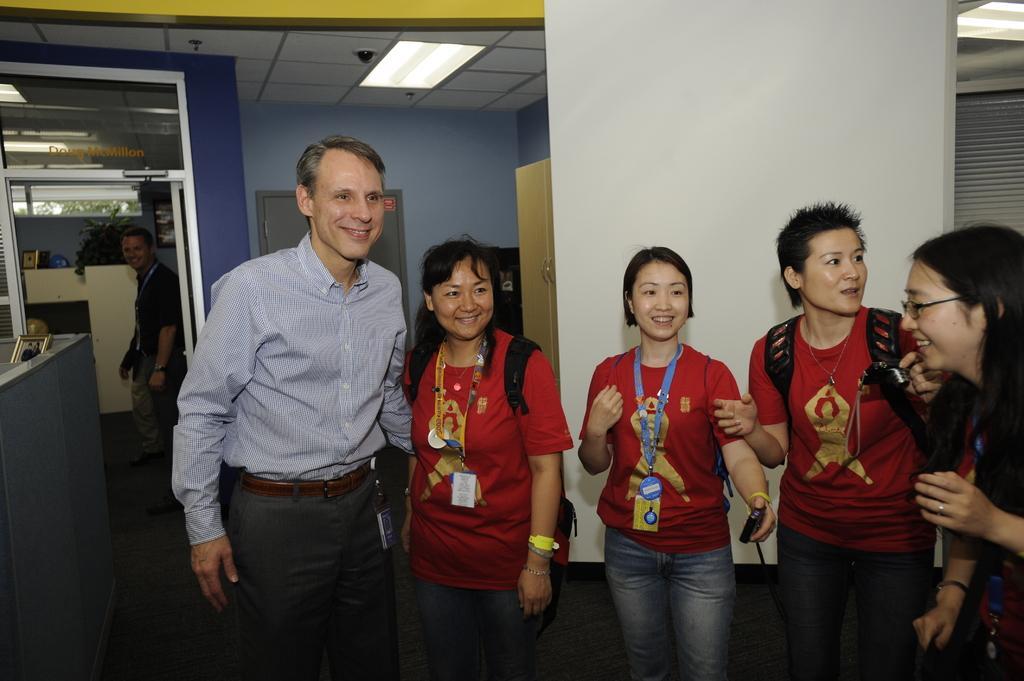How would you summarize this image in a sentence or two? In front of the image there are people having a smile on their faces. Behind them there are two other people standing. On the right side of the image there is a wardrobe and there is some object. On the left side of the image there is a photo frame on the table. There is a flower pot and some other objects on the platform. There is a door. There is a glass window through which we can see trees. In the background of the image there is a wall. On top of the image there are lights. 